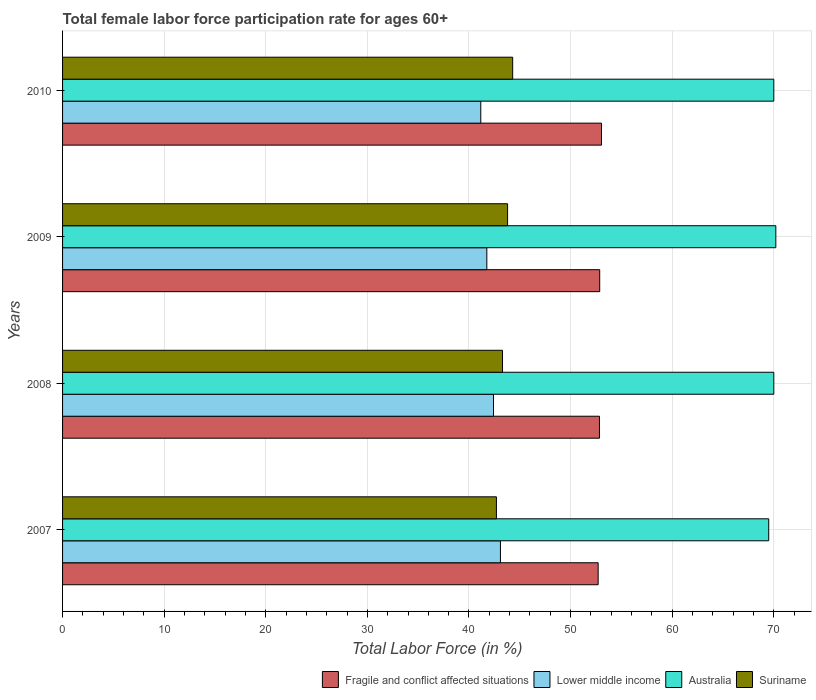How many different coloured bars are there?
Offer a very short reply. 4. How many groups of bars are there?
Ensure brevity in your answer.  4. Are the number of bars on each tick of the Y-axis equal?
Make the answer very short. Yes. How many bars are there on the 4th tick from the top?
Your answer should be very brief. 4. In how many cases, is the number of bars for a given year not equal to the number of legend labels?
Offer a very short reply. 0. What is the female labor force participation rate in Lower middle income in 2007?
Offer a very short reply. 43.1. Across all years, what is the maximum female labor force participation rate in Fragile and conflict affected situations?
Keep it short and to the point. 53.04. Across all years, what is the minimum female labor force participation rate in Lower middle income?
Give a very brief answer. 41.16. What is the total female labor force participation rate in Fragile and conflict affected situations in the graph?
Provide a succinct answer. 211.46. What is the difference between the female labor force participation rate in Fragile and conflict affected situations in 2007 and that in 2008?
Your response must be concise. -0.13. What is the difference between the female labor force participation rate in Lower middle income in 2009 and the female labor force participation rate in Fragile and conflict affected situations in 2008?
Provide a short and direct response. -11.09. What is the average female labor force participation rate in Fragile and conflict affected situations per year?
Your answer should be compact. 52.87. In the year 2008, what is the difference between the female labor force participation rate in Suriname and female labor force participation rate in Australia?
Offer a terse response. -26.7. What is the ratio of the female labor force participation rate in Lower middle income in 2007 to that in 2008?
Give a very brief answer. 1.02. Is the female labor force participation rate in Suriname in 2007 less than that in 2008?
Your response must be concise. Yes. Is the difference between the female labor force participation rate in Suriname in 2007 and 2008 greater than the difference between the female labor force participation rate in Australia in 2007 and 2008?
Offer a terse response. No. What is the difference between the highest and the second highest female labor force participation rate in Australia?
Ensure brevity in your answer.  0.2. What is the difference between the highest and the lowest female labor force participation rate in Lower middle income?
Your answer should be very brief. 1.93. In how many years, is the female labor force participation rate in Australia greater than the average female labor force participation rate in Australia taken over all years?
Ensure brevity in your answer.  3. Is the sum of the female labor force participation rate in Australia in 2007 and 2009 greater than the maximum female labor force participation rate in Suriname across all years?
Make the answer very short. Yes. Is it the case that in every year, the sum of the female labor force participation rate in Australia and female labor force participation rate in Lower middle income is greater than the sum of female labor force participation rate in Fragile and conflict affected situations and female labor force participation rate in Suriname?
Ensure brevity in your answer.  No. What does the 4th bar from the top in 2007 represents?
Your response must be concise. Fragile and conflict affected situations. What does the 4th bar from the bottom in 2010 represents?
Provide a succinct answer. Suriname. How many bars are there?
Offer a terse response. 16. Are the values on the major ticks of X-axis written in scientific E-notation?
Keep it short and to the point. No. Where does the legend appear in the graph?
Ensure brevity in your answer.  Bottom right. What is the title of the graph?
Make the answer very short. Total female labor force participation rate for ages 60+. Does "Malawi" appear as one of the legend labels in the graph?
Provide a short and direct response. No. What is the label or title of the Y-axis?
Your answer should be very brief. Years. What is the Total Labor Force (in %) of Fragile and conflict affected situations in 2007?
Your answer should be compact. 52.71. What is the Total Labor Force (in %) of Lower middle income in 2007?
Keep it short and to the point. 43.1. What is the Total Labor Force (in %) of Australia in 2007?
Give a very brief answer. 69.5. What is the Total Labor Force (in %) of Suriname in 2007?
Ensure brevity in your answer.  42.7. What is the Total Labor Force (in %) of Fragile and conflict affected situations in 2008?
Ensure brevity in your answer.  52.84. What is the Total Labor Force (in %) in Lower middle income in 2008?
Ensure brevity in your answer.  42.41. What is the Total Labor Force (in %) of Australia in 2008?
Offer a very short reply. 70. What is the Total Labor Force (in %) in Suriname in 2008?
Provide a succinct answer. 43.3. What is the Total Labor Force (in %) of Fragile and conflict affected situations in 2009?
Make the answer very short. 52.87. What is the Total Labor Force (in %) in Lower middle income in 2009?
Offer a very short reply. 41.76. What is the Total Labor Force (in %) of Australia in 2009?
Offer a very short reply. 70.2. What is the Total Labor Force (in %) in Suriname in 2009?
Your response must be concise. 43.8. What is the Total Labor Force (in %) of Fragile and conflict affected situations in 2010?
Keep it short and to the point. 53.04. What is the Total Labor Force (in %) in Lower middle income in 2010?
Provide a succinct answer. 41.16. What is the Total Labor Force (in %) in Suriname in 2010?
Provide a short and direct response. 44.3. Across all years, what is the maximum Total Labor Force (in %) in Fragile and conflict affected situations?
Provide a succinct answer. 53.04. Across all years, what is the maximum Total Labor Force (in %) in Lower middle income?
Your answer should be very brief. 43.1. Across all years, what is the maximum Total Labor Force (in %) in Australia?
Your answer should be compact. 70.2. Across all years, what is the maximum Total Labor Force (in %) of Suriname?
Provide a short and direct response. 44.3. Across all years, what is the minimum Total Labor Force (in %) of Fragile and conflict affected situations?
Your answer should be compact. 52.71. Across all years, what is the minimum Total Labor Force (in %) of Lower middle income?
Ensure brevity in your answer.  41.16. Across all years, what is the minimum Total Labor Force (in %) in Australia?
Make the answer very short. 69.5. Across all years, what is the minimum Total Labor Force (in %) in Suriname?
Your answer should be very brief. 42.7. What is the total Total Labor Force (in %) in Fragile and conflict affected situations in the graph?
Keep it short and to the point. 211.46. What is the total Total Labor Force (in %) in Lower middle income in the graph?
Give a very brief answer. 168.42. What is the total Total Labor Force (in %) of Australia in the graph?
Make the answer very short. 279.7. What is the total Total Labor Force (in %) in Suriname in the graph?
Give a very brief answer. 174.1. What is the difference between the Total Labor Force (in %) of Fragile and conflict affected situations in 2007 and that in 2008?
Make the answer very short. -0.13. What is the difference between the Total Labor Force (in %) in Lower middle income in 2007 and that in 2008?
Keep it short and to the point. 0.68. What is the difference between the Total Labor Force (in %) of Suriname in 2007 and that in 2008?
Make the answer very short. -0.6. What is the difference between the Total Labor Force (in %) of Fragile and conflict affected situations in 2007 and that in 2009?
Provide a short and direct response. -0.15. What is the difference between the Total Labor Force (in %) in Lower middle income in 2007 and that in 2009?
Your answer should be compact. 1.34. What is the difference between the Total Labor Force (in %) of Suriname in 2007 and that in 2009?
Provide a short and direct response. -1.1. What is the difference between the Total Labor Force (in %) of Fragile and conflict affected situations in 2007 and that in 2010?
Provide a succinct answer. -0.33. What is the difference between the Total Labor Force (in %) in Lower middle income in 2007 and that in 2010?
Make the answer very short. 1.93. What is the difference between the Total Labor Force (in %) in Australia in 2007 and that in 2010?
Give a very brief answer. -0.5. What is the difference between the Total Labor Force (in %) of Suriname in 2007 and that in 2010?
Your answer should be very brief. -1.6. What is the difference between the Total Labor Force (in %) of Fragile and conflict affected situations in 2008 and that in 2009?
Ensure brevity in your answer.  -0.02. What is the difference between the Total Labor Force (in %) of Lower middle income in 2008 and that in 2009?
Your response must be concise. 0.66. What is the difference between the Total Labor Force (in %) of Australia in 2008 and that in 2009?
Your response must be concise. -0.2. What is the difference between the Total Labor Force (in %) in Fragile and conflict affected situations in 2008 and that in 2010?
Give a very brief answer. -0.2. What is the difference between the Total Labor Force (in %) of Lower middle income in 2008 and that in 2010?
Your answer should be very brief. 1.25. What is the difference between the Total Labor Force (in %) in Australia in 2008 and that in 2010?
Your answer should be very brief. 0. What is the difference between the Total Labor Force (in %) of Suriname in 2008 and that in 2010?
Provide a succinct answer. -1. What is the difference between the Total Labor Force (in %) in Fragile and conflict affected situations in 2009 and that in 2010?
Make the answer very short. -0.18. What is the difference between the Total Labor Force (in %) of Lower middle income in 2009 and that in 2010?
Provide a short and direct response. 0.59. What is the difference between the Total Labor Force (in %) of Fragile and conflict affected situations in 2007 and the Total Labor Force (in %) of Lower middle income in 2008?
Provide a short and direct response. 10.3. What is the difference between the Total Labor Force (in %) of Fragile and conflict affected situations in 2007 and the Total Labor Force (in %) of Australia in 2008?
Give a very brief answer. -17.29. What is the difference between the Total Labor Force (in %) in Fragile and conflict affected situations in 2007 and the Total Labor Force (in %) in Suriname in 2008?
Give a very brief answer. 9.41. What is the difference between the Total Labor Force (in %) in Lower middle income in 2007 and the Total Labor Force (in %) in Australia in 2008?
Your answer should be compact. -26.9. What is the difference between the Total Labor Force (in %) in Lower middle income in 2007 and the Total Labor Force (in %) in Suriname in 2008?
Provide a succinct answer. -0.2. What is the difference between the Total Labor Force (in %) in Australia in 2007 and the Total Labor Force (in %) in Suriname in 2008?
Provide a succinct answer. 26.2. What is the difference between the Total Labor Force (in %) in Fragile and conflict affected situations in 2007 and the Total Labor Force (in %) in Lower middle income in 2009?
Your answer should be compact. 10.96. What is the difference between the Total Labor Force (in %) in Fragile and conflict affected situations in 2007 and the Total Labor Force (in %) in Australia in 2009?
Make the answer very short. -17.49. What is the difference between the Total Labor Force (in %) of Fragile and conflict affected situations in 2007 and the Total Labor Force (in %) of Suriname in 2009?
Your response must be concise. 8.91. What is the difference between the Total Labor Force (in %) of Lower middle income in 2007 and the Total Labor Force (in %) of Australia in 2009?
Make the answer very short. -27.1. What is the difference between the Total Labor Force (in %) in Lower middle income in 2007 and the Total Labor Force (in %) in Suriname in 2009?
Provide a short and direct response. -0.7. What is the difference between the Total Labor Force (in %) of Australia in 2007 and the Total Labor Force (in %) of Suriname in 2009?
Make the answer very short. 25.7. What is the difference between the Total Labor Force (in %) of Fragile and conflict affected situations in 2007 and the Total Labor Force (in %) of Lower middle income in 2010?
Provide a short and direct response. 11.55. What is the difference between the Total Labor Force (in %) of Fragile and conflict affected situations in 2007 and the Total Labor Force (in %) of Australia in 2010?
Keep it short and to the point. -17.29. What is the difference between the Total Labor Force (in %) of Fragile and conflict affected situations in 2007 and the Total Labor Force (in %) of Suriname in 2010?
Your response must be concise. 8.41. What is the difference between the Total Labor Force (in %) in Lower middle income in 2007 and the Total Labor Force (in %) in Australia in 2010?
Your answer should be very brief. -26.9. What is the difference between the Total Labor Force (in %) in Lower middle income in 2007 and the Total Labor Force (in %) in Suriname in 2010?
Make the answer very short. -1.2. What is the difference between the Total Labor Force (in %) of Australia in 2007 and the Total Labor Force (in %) of Suriname in 2010?
Your response must be concise. 25.2. What is the difference between the Total Labor Force (in %) of Fragile and conflict affected situations in 2008 and the Total Labor Force (in %) of Lower middle income in 2009?
Make the answer very short. 11.09. What is the difference between the Total Labor Force (in %) of Fragile and conflict affected situations in 2008 and the Total Labor Force (in %) of Australia in 2009?
Keep it short and to the point. -17.36. What is the difference between the Total Labor Force (in %) of Fragile and conflict affected situations in 2008 and the Total Labor Force (in %) of Suriname in 2009?
Your answer should be compact. 9.04. What is the difference between the Total Labor Force (in %) in Lower middle income in 2008 and the Total Labor Force (in %) in Australia in 2009?
Keep it short and to the point. -27.79. What is the difference between the Total Labor Force (in %) in Lower middle income in 2008 and the Total Labor Force (in %) in Suriname in 2009?
Ensure brevity in your answer.  -1.39. What is the difference between the Total Labor Force (in %) of Australia in 2008 and the Total Labor Force (in %) of Suriname in 2009?
Give a very brief answer. 26.2. What is the difference between the Total Labor Force (in %) in Fragile and conflict affected situations in 2008 and the Total Labor Force (in %) in Lower middle income in 2010?
Keep it short and to the point. 11.68. What is the difference between the Total Labor Force (in %) in Fragile and conflict affected situations in 2008 and the Total Labor Force (in %) in Australia in 2010?
Keep it short and to the point. -17.16. What is the difference between the Total Labor Force (in %) of Fragile and conflict affected situations in 2008 and the Total Labor Force (in %) of Suriname in 2010?
Your answer should be very brief. 8.54. What is the difference between the Total Labor Force (in %) of Lower middle income in 2008 and the Total Labor Force (in %) of Australia in 2010?
Provide a short and direct response. -27.59. What is the difference between the Total Labor Force (in %) of Lower middle income in 2008 and the Total Labor Force (in %) of Suriname in 2010?
Ensure brevity in your answer.  -1.89. What is the difference between the Total Labor Force (in %) in Australia in 2008 and the Total Labor Force (in %) in Suriname in 2010?
Your answer should be compact. 25.7. What is the difference between the Total Labor Force (in %) of Fragile and conflict affected situations in 2009 and the Total Labor Force (in %) of Lower middle income in 2010?
Keep it short and to the point. 11.7. What is the difference between the Total Labor Force (in %) of Fragile and conflict affected situations in 2009 and the Total Labor Force (in %) of Australia in 2010?
Provide a short and direct response. -17.13. What is the difference between the Total Labor Force (in %) of Fragile and conflict affected situations in 2009 and the Total Labor Force (in %) of Suriname in 2010?
Your answer should be very brief. 8.57. What is the difference between the Total Labor Force (in %) in Lower middle income in 2009 and the Total Labor Force (in %) in Australia in 2010?
Give a very brief answer. -28.24. What is the difference between the Total Labor Force (in %) of Lower middle income in 2009 and the Total Labor Force (in %) of Suriname in 2010?
Offer a very short reply. -2.54. What is the difference between the Total Labor Force (in %) in Australia in 2009 and the Total Labor Force (in %) in Suriname in 2010?
Offer a terse response. 25.9. What is the average Total Labor Force (in %) in Fragile and conflict affected situations per year?
Your answer should be very brief. 52.87. What is the average Total Labor Force (in %) in Lower middle income per year?
Offer a terse response. 42.11. What is the average Total Labor Force (in %) of Australia per year?
Ensure brevity in your answer.  69.92. What is the average Total Labor Force (in %) of Suriname per year?
Ensure brevity in your answer.  43.52. In the year 2007, what is the difference between the Total Labor Force (in %) in Fragile and conflict affected situations and Total Labor Force (in %) in Lower middle income?
Your answer should be compact. 9.62. In the year 2007, what is the difference between the Total Labor Force (in %) in Fragile and conflict affected situations and Total Labor Force (in %) in Australia?
Your answer should be compact. -16.79. In the year 2007, what is the difference between the Total Labor Force (in %) of Fragile and conflict affected situations and Total Labor Force (in %) of Suriname?
Your response must be concise. 10.01. In the year 2007, what is the difference between the Total Labor Force (in %) of Lower middle income and Total Labor Force (in %) of Australia?
Keep it short and to the point. -26.4. In the year 2007, what is the difference between the Total Labor Force (in %) in Lower middle income and Total Labor Force (in %) in Suriname?
Give a very brief answer. 0.4. In the year 2007, what is the difference between the Total Labor Force (in %) in Australia and Total Labor Force (in %) in Suriname?
Provide a short and direct response. 26.8. In the year 2008, what is the difference between the Total Labor Force (in %) in Fragile and conflict affected situations and Total Labor Force (in %) in Lower middle income?
Give a very brief answer. 10.43. In the year 2008, what is the difference between the Total Labor Force (in %) of Fragile and conflict affected situations and Total Labor Force (in %) of Australia?
Offer a terse response. -17.16. In the year 2008, what is the difference between the Total Labor Force (in %) of Fragile and conflict affected situations and Total Labor Force (in %) of Suriname?
Your answer should be very brief. 9.54. In the year 2008, what is the difference between the Total Labor Force (in %) in Lower middle income and Total Labor Force (in %) in Australia?
Keep it short and to the point. -27.59. In the year 2008, what is the difference between the Total Labor Force (in %) in Lower middle income and Total Labor Force (in %) in Suriname?
Provide a short and direct response. -0.89. In the year 2008, what is the difference between the Total Labor Force (in %) in Australia and Total Labor Force (in %) in Suriname?
Your response must be concise. 26.7. In the year 2009, what is the difference between the Total Labor Force (in %) in Fragile and conflict affected situations and Total Labor Force (in %) in Lower middle income?
Make the answer very short. 11.11. In the year 2009, what is the difference between the Total Labor Force (in %) of Fragile and conflict affected situations and Total Labor Force (in %) of Australia?
Make the answer very short. -17.33. In the year 2009, what is the difference between the Total Labor Force (in %) of Fragile and conflict affected situations and Total Labor Force (in %) of Suriname?
Make the answer very short. 9.07. In the year 2009, what is the difference between the Total Labor Force (in %) of Lower middle income and Total Labor Force (in %) of Australia?
Offer a terse response. -28.44. In the year 2009, what is the difference between the Total Labor Force (in %) in Lower middle income and Total Labor Force (in %) in Suriname?
Make the answer very short. -2.04. In the year 2009, what is the difference between the Total Labor Force (in %) in Australia and Total Labor Force (in %) in Suriname?
Your response must be concise. 26.4. In the year 2010, what is the difference between the Total Labor Force (in %) of Fragile and conflict affected situations and Total Labor Force (in %) of Lower middle income?
Your answer should be very brief. 11.88. In the year 2010, what is the difference between the Total Labor Force (in %) in Fragile and conflict affected situations and Total Labor Force (in %) in Australia?
Give a very brief answer. -16.96. In the year 2010, what is the difference between the Total Labor Force (in %) in Fragile and conflict affected situations and Total Labor Force (in %) in Suriname?
Give a very brief answer. 8.74. In the year 2010, what is the difference between the Total Labor Force (in %) of Lower middle income and Total Labor Force (in %) of Australia?
Keep it short and to the point. -28.84. In the year 2010, what is the difference between the Total Labor Force (in %) of Lower middle income and Total Labor Force (in %) of Suriname?
Your answer should be very brief. -3.14. In the year 2010, what is the difference between the Total Labor Force (in %) of Australia and Total Labor Force (in %) of Suriname?
Provide a succinct answer. 25.7. What is the ratio of the Total Labor Force (in %) in Lower middle income in 2007 to that in 2008?
Make the answer very short. 1.02. What is the ratio of the Total Labor Force (in %) of Suriname in 2007 to that in 2008?
Your answer should be compact. 0.99. What is the ratio of the Total Labor Force (in %) of Lower middle income in 2007 to that in 2009?
Your answer should be very brief. 1.03. What is the ratio of the Total Labor Force (in %) of Australia in 2007 to that in 2009?
Keep it short and to the point. 0.99. What is the ratio of the Total Labor Force (in %) of Suriname in 2007 to that in 2009?
Give a very brief answer. 0.97. What is the ratio of the Total Labor Force (in %) of Fragile and conflict affected situations in 2007 to that in 2010?
Provide a succinct answer. 0.99. What is the ratio of the Total Labor Force (in %) in Lower middle income in 2007 to that in 2010?
Provide a succinct answer. 1.05. What is the ratio of the Total Labor Force (in %) of Suriname in 2007 to that in 2010?
Give a very brief answer. 0.96. What is the ratio of the Total Labor Force (in %) in Lower middle income in 2008 to that in 2009?
Give a very brief answer. 1.02. What is the ratio of the Total Labor Force (in %) of Australia in 2008 to that in 2009?
Keep it short and to the point. 1. What is the ratio of the Total Labor Force (in %) in Suriname in 2008 to that in 2009?
Ensure brevity in your answer.  0.99. What is the ratio of the Total Labor Force (in %) of Fragile and conflict affected situations in 2008 to that in 2010?
Ensure brevity in your answer.  1. What is the ratio of the Total Labor Force (in %) in Lower middle income in 2008 to that in 2010?
Your answer should be very brief. 1.03. What is the ratio of the Total Labor Force (in %) of Suriname in 2008 to that in 2010?
Keep it short and to the point. 0.98. What is the ratio of the Total Labor Force (in %) of Fragile and conflict affected situations in 2009 to that in 2010?
Provide a short and direct response. 1. What is the ratio of the Total Labor Force (in %) in Lower middle income in 2009 to that in 2010?
Make the answer very short. 1.01. What is the ratio of the Total Labor Force (in %) of Australia in 2009 to that in 2010?
Your answer should be very brief. 1. What is the ratio of the Total Labor Force (in %) of Suriname in 2009 to that in 2010?
Your answer should be compact. 0.99. What is the difference between the highest and the second highest Total Labor Force (in %) in Fragile and conflict affected situations?
Ensure brevity in your answer.  0.18. What is the difference between the highest and the second highest Total Labor Force (in %) in Lower middle income?
Ensure brevity in your answer.  0.68. What is the difference between the highest and the second highest Total Labor Force (in %) of Australia?
Provide a succinct answer. 0.2. What is the difference between the highest and the second highest Total Labor Force (in %) in Suriname?
Make the answer very short. 0.5. What is the difference between the highest and the lowest Total Labor Force (in %) in Fragile and conflict affected situations?
Ensure brevity in your answer.  0.33. What is the difference between the highest and the lowest Total Labor Force (in %) in Lower middle income?
Provide a short and direct response. 1.93. What is the difference between the highest and the lowest Total Labor Force (in %) in Australia?
Ensure brevity in your answer.  0.7. 